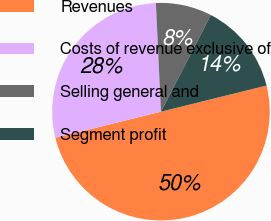Convert chart. <chart><loc_0><loc_0><loc_500><loc_500><pie_chart><fcel>Revenues<fcel>Costs of revenue exclusive of<fcel>Selling general and<fcel>Segment profit<nl><fcel>50.0%<fcel>28.12%<fcel>8.32%<fcel>13.56%<nl></chart> 